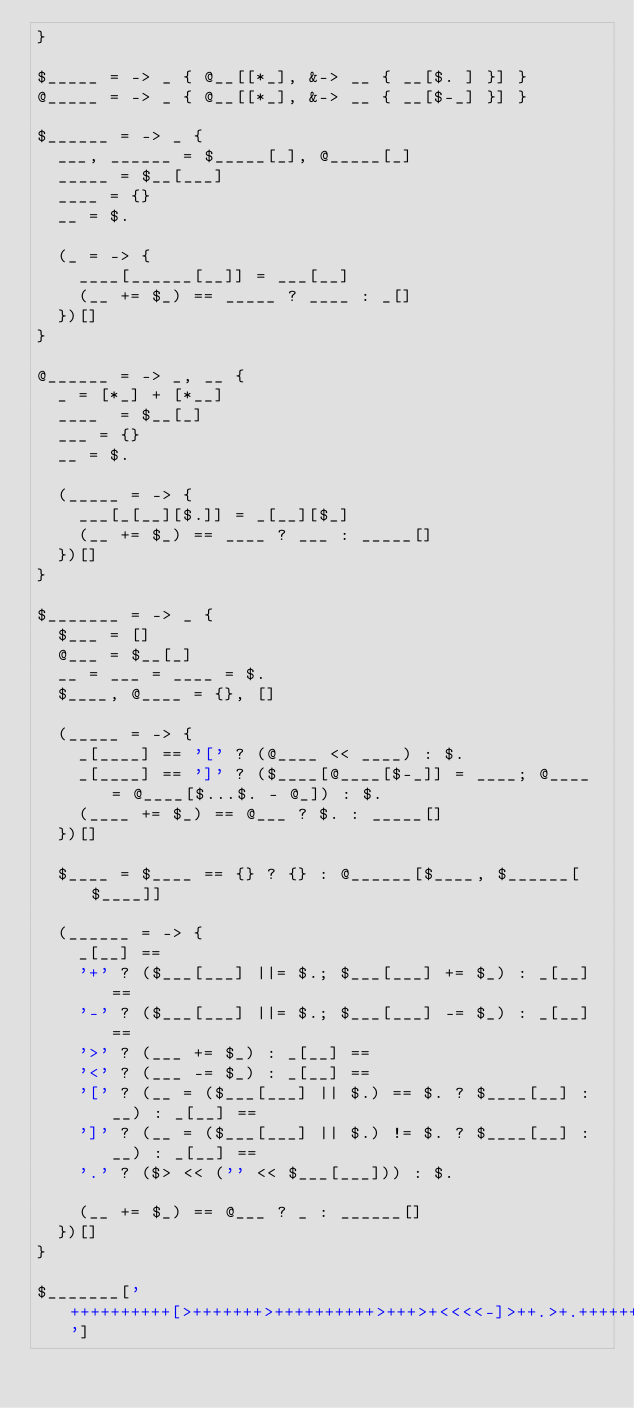<code> <loc_0><loc_0><loc_500><loc_500><_Ruby_>}

$_____ = -> _ { @__[[*_], &-> __ { __[$. ] }] }
@_____ = -> _ { @__[[*_], &-> __ { __[$-_] }] }

$______ = -> _ {
  ___, ______ = $_____[_], @_____[_]
  _____ = $__[___]
  ____ = {}
  __ = $.

  (_ = -> {
    ____[______[__]] = ___[__]
    (__ += $_) == _____ ? ____ : _[]
  })[]
}

@______ = -> _, __ {
  _ = [*_] + [*__]
  ____  = $__[_]
  ___ = {}
  __ = $.

  (_____ = -> {
    ___[_[__][$.]] = _[__][$_]
    (__ += $_) == ____ ? ___ : _____[]
  })[]
}

$_______ = -> _ {
  $___ = []
  @___ = $__[_]
  __ = ___ = ____ = $.
  $____, @____ = {}, []

  (_____ = -> {
    _[____] == '[' ? (@____ << ____) : $.
    _[____] == ']' ? ($____[@____[$-_]] = ____; @____ = @____[$...$. - @_]) : $.
    (____ += $_) == @___ ? $. : _____[]
  })[]

  $____ = $____ == {} ? {} : @______[$____, $______[$____]]

  (______ = -> {
    _[__] ==
    '+' ? ($___[___] ||= $.; $___[___] += $_) : _[__] ==
    '-' ? ($___[___] ||= $.; $___[___] -= $_) : _[__] ==
    '>' ? (___ += $_) : _[__] ==
    '<' ? (___ -= $_) : _[__] ==
    '[' ? (__ = ($___[___] || $.) == $. ? $____[__] : __) : _[__] ==
    ']' ? (__ = ($___[___] || $.) != $. ? $____[__] : __) : _[__] ==
    '.' ? ($> << ('' << $___[___])) : $.

    (__ += $_) == @___ ? _ : ______[]
  })[]
}

$_______['++++++++++[>+++++++>++++++++++>+++>+<<<<-]>++.>+.+++++++..+++.>++.<<+++++++++++++++.>.+++.------.--------.>+.>.']
</code> 